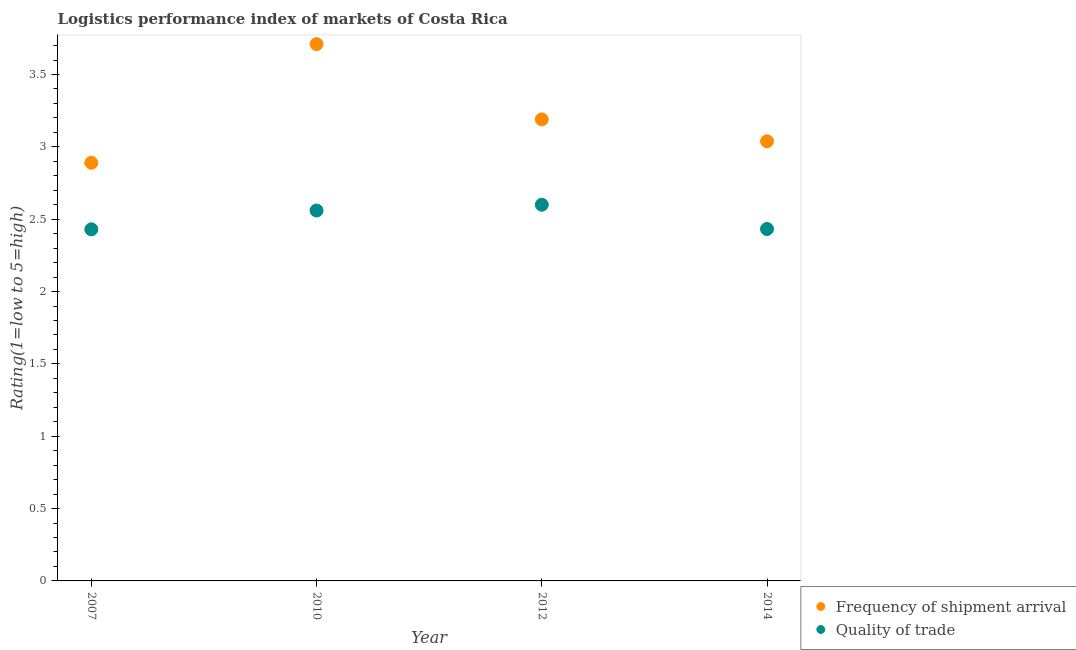How many different coloured dotlines are there?
Keep it short and to the point. 2. What is the lpi quality of trade in 2014?
Your response must be concise. 2.43. Across all years, what is the maximum lpi of frequency of shipment arrival?
Ensure brevity in your answer.  3.71. Across all years, what is the minimum lpi of frequency of shipment arrival?
Provide a short and direct response. 2.89. What is the total lpi quality of trade in the graph?
Your answer should be very brief. 10.02. What is the difference between the lpi quality of trade in 2010 and that in 2012?
Provide a succinct answer. -0.04. What is the difference between the lpi of frequency of shipment arrival in 2014 and the lpi quality of trade in 2012?
Keep it short and to the point. 0.44. What is the average lpi quality of trade per year?
Your response must be concise. 2.51. In the year 2010, what is the difference between the lpi of frequency of shipment arrival and lpi quality of trade?
Your response must be concise. 1.15. What is the ratio of the lpi of frequency of shipment arrival in 2007 to that in 2014?
Offer a terse response. 0.95. Is the lpi quality of trade in 2007 less than that in 2014?
Your answer should be very brief. Yes. Is the difference between the lpi of frequency of shipment arrival in 2010 and 2014 greater than the difference between the lpi quality of trade in 2010 and 2014?
Your answer should be compact. Yes. What is the difference between the highest and the second highest lpi quality of trade?
Ensure brevity in your answer.  0.04. What is the difference between the highest and the lowest lpi quality of trade?
Make the answer very short. 0.17. In how many years, is the lpi quality of trade greater than the average lpi quality of trade taken over all years?
Your response must be concise. 2. Does the lpi of frequency of shipment arrival monotonically increase over the years?
Provide a short and direct response. No. Is the lpi quality of trade strictly greater than the lpi of frequency of shipment arrival over the years?
Offer a terse response. No. How many years are there in the graph?
Provide a succinct answer. 4. What is the difference between two consecutive major ticks on the Y-axis?
Your answer should be compact. 0.5. Are the values on the major ticks of Y-axis written in scientific E-notation?
Your answer should be compact. No. Where does the legend appear in the graph?
Offer a terse response. Bottom right. How many legend labels are there?
Provide a short and direct response. 2. What is the title of the graph?
Your answer should be very brief. Logistics performance index of markets of Costa Rica. What is the label or title of the X-axis?
Your answer should be very brief. Year. What is the label or title of the Y-axis?
Your answer should be compact. Rating(1=low to 5=high). What is the Rating(1=low to 5=high) of Frequency of shipment arrival in 2007?
Your answer should be compact. 2.89. What is the Rating(1=low to 5=high) of Quality of trade in 2007?
Make the answer very short. 2.43. What is the Rating(1=low to 5=high) in Frequency of shipment arrival in 2010?
Make the answer very short. 3.71. What is the Rating(1=low to 5=high) in Quality of trade in 2010?
Give a very brief answer. 2.56. What is the Rating(1=low to 5=high) of Frequency of shipment arrival in 2012?
Keep it short and to the point. 3.19. What is the Rating(1=low to 5=high) of Quality of trade in 2012?
Provide a short and direct response. 2.6. What is the Rating(1=low to 5=high) of Frequency of shipment arrival in 2014?
Provide a short and direct response. 3.04. What is the Rating(1=low to 5=high) of Quality of trade in 2014?
Provide a succinct answer. 2.43. Across all years, what is the maximum Rating(1=low to 5=high) in Frequency of shipment arrival?
Your answer should be compact. 3.71. Across all years, what is the maximum Rating(1=low to 5=high) in Quality of trade?
Offer a terse response. 2.6. Across all years, what is the minimum Rating(1=low to 5=high) of Frequency of shipment arrival?
Ensure brevity in your answer.  2.89. Across all years, what is the minimum Rating(1=low to 5=high) in Quality of trade?
Your response must be concise. 2.43. What is the total Rating(1=low to 5=high) in Frequency of shipment arrival in the graph?
Provide a short and direct response. 12.83. What is the total Rating(1=low to 5=high) in Quality of trade in the graph?
Your response must be concise. 10.02. What is the difference between the Rating(1=low to 5=high) in Frequency of shipment arrival in 2007 and that in 2010?
Keep it short and to the point. -0.82. What is the difference between the Rating(1=low to 5=high) of Quality of trade in 2007 and that in 2010?
Provide a succinct answer. -0.13. What is the difference between the Rating(1=low to 5=high) of Frequency of shipment arrival in 2007 and that in 2012?
Keep it short and to the point. -0.3. What is the difference between the Rating(1=low to 5=high) in Quality of trade in 2007 and that in 2012?
Your answer should be compact. -0.17. What is the difference between the Rating(1=low to 5=high) of Frequency of shipment arrival in 2007 and that in 2014?
Ensure brevity in your answer.  -0.15. What is the difference between the Rating(1=low to 5=high) in Quality of trade in 2007 and that in 2014?
Your answer should be very brief. -0. What is the difference between the Rating(1=low to 5=high) in Frequency of shipment arrival in 2010 and that in 2012?
Ensure brevity in your answer.  0.52. What is the difference between the Rating(1=low to 5=high) in Quality of trade in 2010 and that in 2012?
Provide a succinct answer. -0.04. What is the difference between the Rating(1=low to 5=high) in Frequency of shipment arrival in 2010 and that in 2014?
Make the answer very short. 0.67. What is the difference between the Rating(1=low to 5=high) in Quality of trade in 2010 and that in 2014?
Offer a terse response. 0.13. What is the difference between the Rating(1=low to 5=high) in Frequency of shipment arrival in 2012 and that in 2014?
Provide a short and direct response. 0.15. What is the difference between the Rating(1=low to 5=high) of Quality of trade in 2012 and that in 2014?
Keep it short and to the point. 0.17. What is the difference between the Rating(1=low to 5=high) in Frequency of shipment arrival in 2007 and the Rating(1=low to 5=high) in Quality of trade in 2010?
Give a very brief answer. 0.33. What is the difference between the Rating(1=low to 5=high) in Frequency of shipment arrival in 2007 and the Rating(1=low to 5=high) in Quality of trade in 2012?
Keep it short and to the point. 0.29. What is the difference between the Rating(1=low to 5=high) of Frequency of shipment arrival in 2007 and the Rating(1=low to 5=high) of Quality of trade in 2014?
Ensure brevity in your answer.  0.46. What is the difference between the Rating(1=low to 5=high) of Frequency of shipment arrival in 2010 and the Rating(1=low to 5=high) of Quality of trade in 2012?
Your answer should be compact. 1.11. What is the difference between the Rating(1=low to 5=high) of Frequency of shipment arrival in 2010 and the Rating(1=low to 5=high) of Quality of trade in 2014?
Your answer should be very brief. 1.28. What is the difference between the Rating(1=low to 5=high) in Frequency of shipment arrival in 2012 and the Rating(1=low to 5=high) in Quality of trade in 2014?
Offer a very short reply. 0.76. What is the average Rating(1=low to 5=high) in Frequency of shipment arrival per year?
Ensure brevity in your answer.  3.21. What is the average Rating(1=low to 5=high) of Quality of trade per year?
Your answer should be very brief. 2.51. In the year 2007, what is the difference between the Rating(1=low to 5=high) of Frequency of shipment arrival and Rating(1=low to 5=high) of Quality of trade?
Ensure brevity in your answer.  0.46. In the year 2010, what is the difference between the Rating(1=low to 5=high) in Frequency of shipment arrival and Rating(1=low to 5=high) in Quality of trade?
Your response must be concise. 1.15. In the year 2012, what is the difference between the Rating(1=low to 5=high) in Frequency of shipment arrival and Rating(1=low to 5=high) in Quality of trade?
Your answer should be very brief. 0.59. In the year 2014, what is the difference between the Rating(1=low to 5=high) of Frequency of shipment arrival and Rating(1=low to 5=high) of Quality of trade?
Your response must be concise. 0.61. What is the ratio of the Rating(1=low to 5=high) in Frequency of shipment arrival in 2007 to that in 2010?
Offer a very short reply. 0.78. What is the ratio of the Rating(1=low to 5=high) of Quality of trade in 2007 to that in 2010?
Your answer should be compact. 0.95. What is the ratio of the Rating(1=low to 5=high) of Frequency of shipment arrival in 2007 to that in 2012?
Your answer should be compact. 0.91. What is the ratio of the Rating(1=low to 5=high) of Quality of trade in 2007 to that in 2012?
Your answer should be very brief. 0.93. What is the ratio of the Rating(1=low to 5=high) of Frequency of shipment arrival in 2007 to that in 2014?
Make the answer very short. 0.95. What is the ratio of the Rating(1=low to 5=high) of Frequency of shipment arrival in 2010 to that in 2012?
Ensure brevity in your answer.  1.16. What is the ratio of the Rating(1=low to 5=high) of Quality of trade in 2010 to that in 2012?
Provide a short and direct response. 0.98. What is the ratio of the Rating(1=low to 5=high) in Frequency of shipment arrival in 2010 to that in 2014?
Offer a very short reply. 1.22. What is the ratio of the Rating(1=low to 5=high) of Quality of trade in 2010 to that in 2014?
Provide a succinct answer. 1.05. What is the ratio of the Rating(1=low to 5=high) of Frequency of shipment arrival in 2012 to that in 2014?
Ensure brevity in your answer.  1.05. What is the ratio of the Rating(1=low to 5=high) of Quality of trade in 2012 to that in 2014?
Keep it short and to the point. 1.07. What is the difference between the highest and the second highest Rating(1=low to 5=high) of Frequency of shipment arrival?
Offer a terse response. 0.52. What is the difference between the highest and the lowest Rating(1=low to 5=high) of Frequency of shipment arrival?
Give a very brief answer. 0.82. What is the difference between the highest and the lowest Rating(1=low to 5=high) of Quality of trade?
Provide a succinct answer. 0.17. 